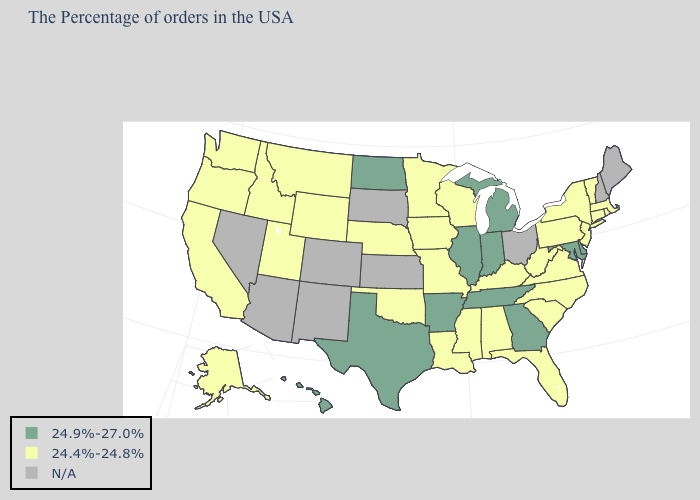What is the value of Alaska?
Concise answer only. 24.4%-24.8%. Which states have the highest value in the USA?
Be succinct. Delaware, Maryland, Georgia, Michigan, Indiana, Tennessee, Illinois, Arkansas, Texas, North Dakota, Hawaii. Name the states that have a value in the range 24.4%-24.8%?
Concise answer only. Massachusetts, Rhode Island, Vermont, Connecticut, New York, New Jersey, Pennsylvania, Virginia, North Carolina, South Carolina, West Virginia, Florida, Kentucky, Alabama, Wisconsin, Mississippi, Louisiana, Missouri, Minnesota, Iowa, Nebraska, Oklahoma, Wyoming, Utah, Montana, Idaho, California, Washington, Oregon, Alaska. What is the value of South Carolina?
Quick response, please. 24.4%-24.8%. What is the value of Louisiana?
Be succinct. 24.4%-24.8%. Which states have the lowest value in the USA?
Keep it brief. Massachusetts, Rhode Island, Vermont, Connecticut, New York, New Jersey, Pennsylvania, Virginia, North Carolina, South Carolina, West Virginia, Florida, Kentucky, Alabama, Wisconsin, Mississippi, Louisiana, Missouri, Minnesota, Iowa, Nebraska, Oklahoma, Wyoming, Utah, Montana, Idaho, California, Washington, Oregon, Alaska. Does the map have missing data?
Give a very brief answer. Yes. What is the value of Rhode Island?
Give a very brief answer. 24.4%-24.8%. What is the value of Kansas?
Write a very short answer. N/A. Among the states that border West Virginia , does Maryland have the lowest value?
Concise answer only. No. Among the states that border Texas , does Oklahoma have the highest value?
Short answer required. No. What is the value of Minnesota?
Concise answer only. 24.4%-24.8%. What is the value of New York?
Short answer required. 24.4%-24.8%. What is the value of Rhode Island?
Give a very brief answer. 24.4%-24.8%. 